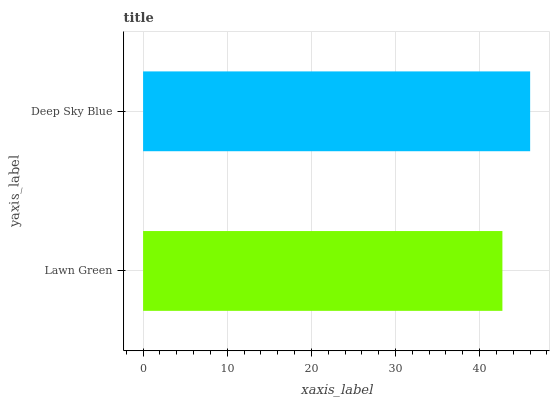Is Lawn Green the minimum?
Answer yes or no. Yes. Is Deep Sky Blue the maximum?
Answer yes or no. Yes. Is Deep Sky Blue the minimum?
Answer yes or no. No. Is Deep Sky Blue greater than Lawn Green?
Answer yes or no. Yes. Is Lawn Green less than Deep Sky Blue?
Answer yes or no. Yes. Is Lawn Green greater than Deep Sky Blue?
Answer yes or no. No. Is Deep Sky Blue less than Lawn Green?
Answer yes or no. No. Is Deep Sky Blue the high median?
Answer yes or no. Yes. Is Lawn Green the low median?
Answer yes or no. Yes. Is Lawn Green the high median?
Answer yes or no. No. Is Deep Sky Blue the low median?
Answer yes or no. No. 